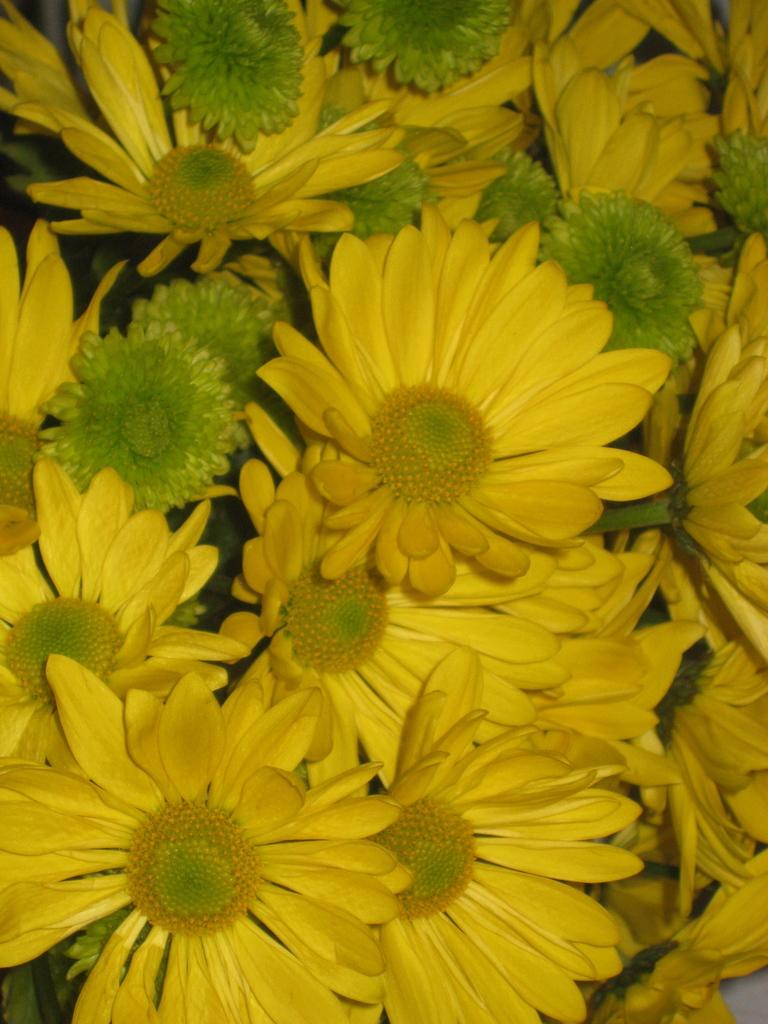What is the main subject of the image? The main subject of the image is a group of flowers. Can you describe the flowers in the image? Unfortunately, the facts provided do not give any details about the flowers, so we cannot describe them. Are there any other objects or elements in the image besides the flowers? The facts provided do not mention any other objects or elements in the image, so we cannot comment on their presence. What type of wristwatch is the judge wearing in the image? There is no judge or wristwatch present in the image; it features a group of flowers. 